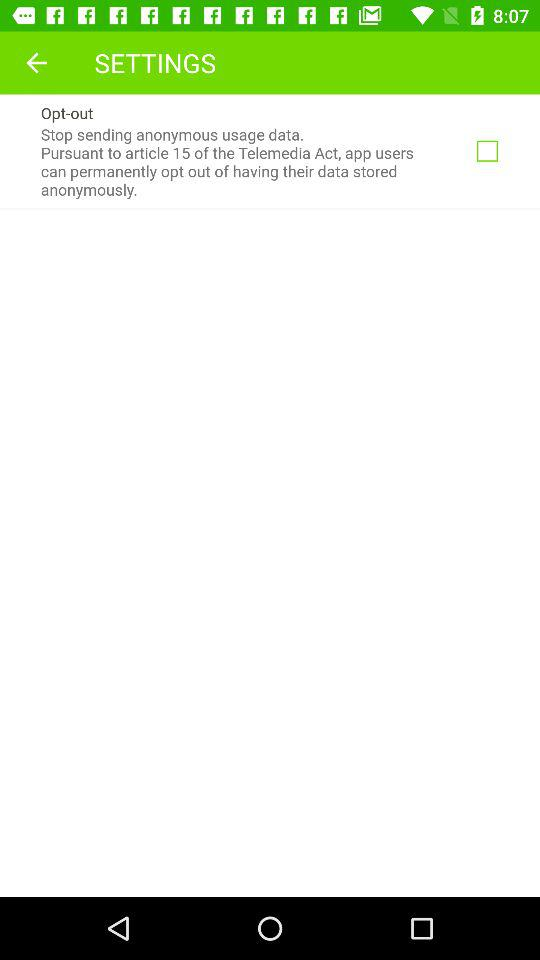What is the status of "Opt-out"? The status is "off". 